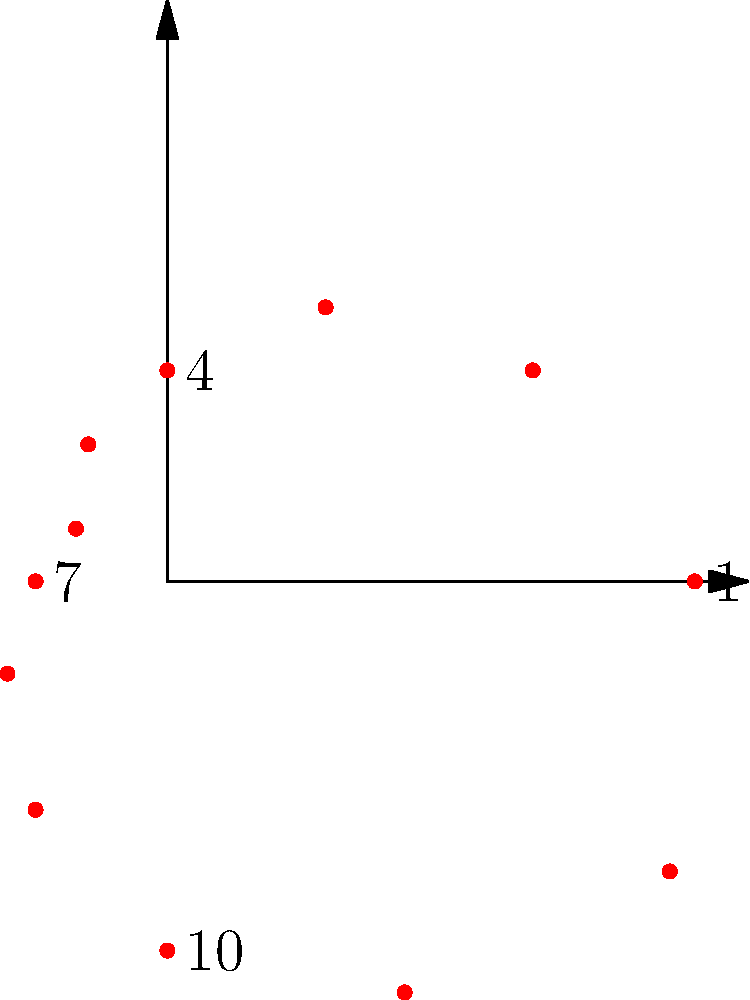In the polar coordinate plot of insurance claim frequencies over a year, which month shows the highest number of claims, and what might be a potential legal implication of this peak for insurance companies in the UK? To answer this question, we need to analyze the polar coordinate plot and consider the legal implications:

1. Interpreting the plot:
   - Each point represents a month, with the distance from the center indicating the number of claims.
   - The months are arranged clockwise, starting from the positive x-axis (3 o'clock position).

2. Identifying the highest peak:
   - The point furthest from the center represents the month with the highest number of claims.
   - This point is located at approximately the 12 o'clock position, corresponding to December (month 12).

3. Legal implications for UK insurance companies:
   - Under UK insurance law, insurers have a duty of utmost good faith (uberrimae fidei) to their policyholders.
   - The peak in December suggests a seasonal trend in claims, which insurers should be aware of and consider in their risk assessment and pricing models.
   - Failure to account for this predictable increase could be seen as a breach of the insurer's duty to properly assess and price risk.

4. Potential legal considerations:
   - The Financial Conduct Authority (FCA) regulations require insurers to treat customers fairly.
   - If insurers do not adjust their policies or premiums to reflect this known risk, it could be considered unfair pricing.
   - There might be a need for clearer disclosure to policyholders about the increased risk during this period.

5. Possible regulatory implications:
   - The FCA might require insurers to demonstrate that they have taken this seasonal variation into account in their pricing and reserving strategies.
   - Failure to do so could result in regulatory action or fines.

Therefore, the legal implication of this peak for UK insurance companies is the potential need to adjust their risk assessment, pricing models, and disclosure practices to ensure compliance with their duty of utmost good faith and FCA regulations.
Answer: December; potential breach of duty of utmost good faith if not factored into risk assessment and pricing. 